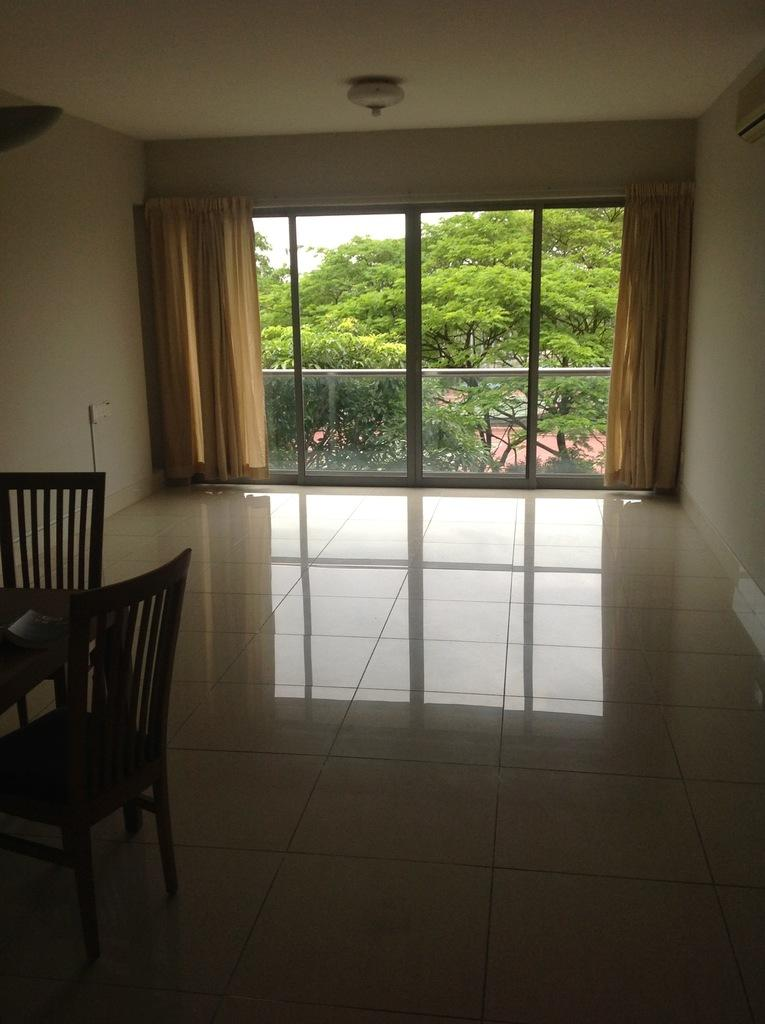What type of location is depicted in the image? The image is an inside view of a room. What furniture can be seen on the left side of the room? There are chairs on the left side of the room. What is attached to the wall in the room? There is a device on the wall. What type of window treatment is present in the room? There are curtains in the room. What can be seen in the background of the image? Trees are visible in the background. Where is the shelf located in the room? There is no shelf present in the image. Can you tell me the name of the sister who is also in the room? There is no person, let alone a sister, present in the image. 